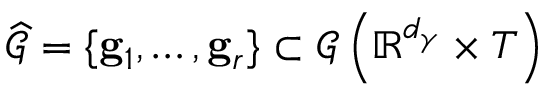<formula> <loc_0><loc_0><loc_500><loc_500>\widehat { \mathcal { G } } = \{ g _ { 1 } , \dots , g _ { r } \} \subset \mathcal { G } \left ( \mathbb { R } ^ { d _ { \gamma } } \times T \right )</formula> 